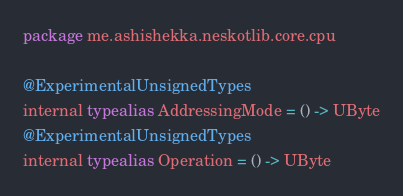<code> <loc_0><loc_0><loc_500><loc_500><_Kotlin_>package me.ashishekka.neskotlib.core.cpu

@ExperimentalUnsignedTypes
internal typealias AddressingMode = () -> UByte
@ExperimentalUnsignedTypes
internal typealias Operation = () -> UByte</code> 